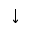Convert formula to latex. <formula><loc_0><loc_0><loc_500><loc_500>\downarrow</formula> 